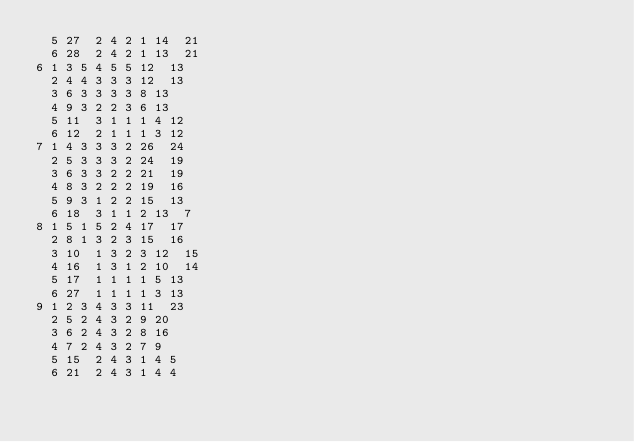Convert code to text. <code><loc_0><loc_0><loc_500><loc_500><_ObjectiveC_>	5	27	2	4	2	1	14	21	
	6	28	2	4	2	1	13	21	
6	1	3	5	4	5	5	12	13	
	2	4	4	3	3	3	12	13	
	3	6	3	3	3	3	8	13	
	4	9	3	2	2	3	6	13	
	5	11	3	1	1	1	4	12	
	6	12	2	1	1	1	3	12	
7	1	4	3	3	3	2	26	24	
	2	5	3	3	3	2	24	19	
	3	6	3	3	2	2	21	19	
	4	8	3	2	2	2	19	16	
	5	9	3	1	2	2	15	13	
	6	18	3	1	1	2	13	7	
8	1	5	1	5	2	4	17	17	
	2	8	1	3	2	3	15	16	
	3	10	1	3	2	3	12	15	
	4	16	1	3	1	2	10	14	
	5	17	1	1	1	1	5	13	
	6	27	1	1	1	1	3	13	
9	1	2	3	4	3	3	11	23	
	2	5	2	4	3	2	9	20	
	3	6	2	4	3	2	8	16	
	4	7	2	4	3	2	7	9	
	5	15	2	4	3	1	4	5	
	6	21	2	4	3	1	4	4	</code> 